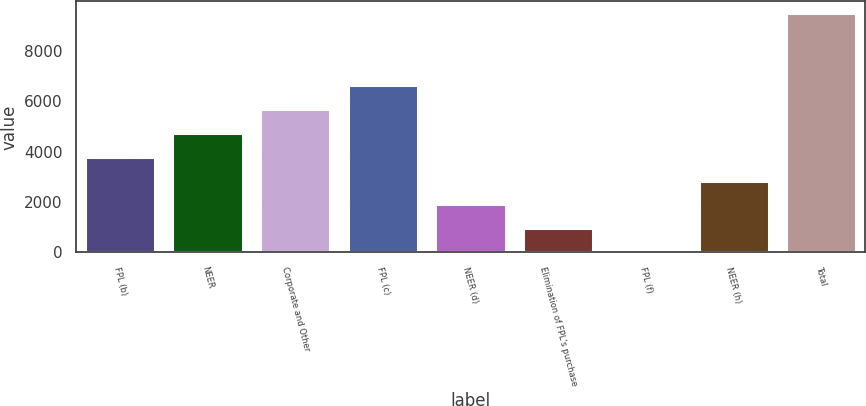<chart> <loc_0><loc_0><loc_500><loc_500><bar_chart><fcel>FPL (b)<fcel>NEER<fcel>Corporate and Other<fcel>FPL (c)<fcel>NEER (d)<fcel>Elimination of FPL's purchase<fcel>FPL (f)<fcel>NEER (h)<fcel>Total<nl><fcel>3800.2<fcel>4749.5<fcel>5698.8<fcel>6648.1<fcel>1901.6<fcel>952.3<fcel>3<fcel>2850.9<fcel>9496<nl></chart> 